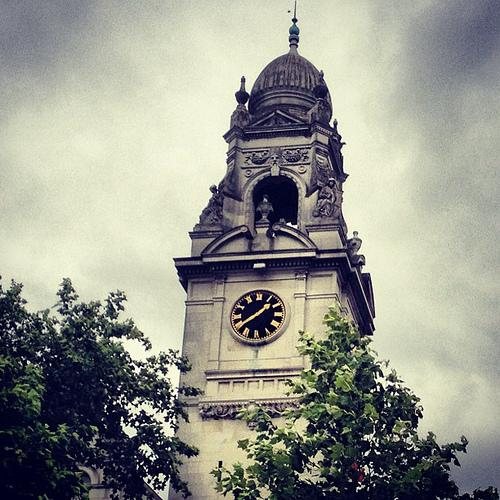Question: who took the picture?
Choices:
A. Man.
B. Woman.
C. Child.
D. The street performer.
Answer with the letter. Answer: A Question: why is it cloudy?
Choices:
A. No sunlight.
B. Wind.
C. It is about to storm.
D. It is raining.
Answer with the letter. Answer: B Question: what is black?
Choices:
A. Clock.
B. The photo.
C. The painting.
D. The windowframe.
Answer with the letter. Answer: A Question: how many clocks?
Choices:
A. Two.
B. Three.
C. One.
D. Four.
Answer with the letter. Answer: C 